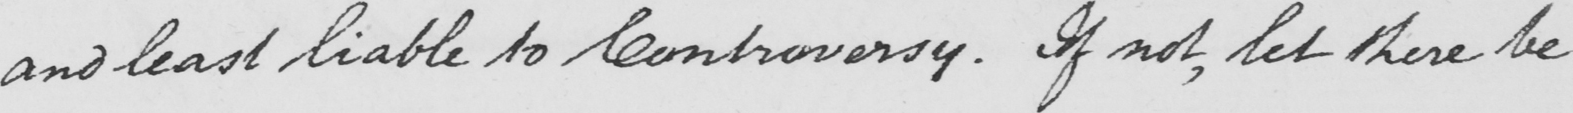Transcribe the text shown in this historical manuscript line. and least liable to Controversy . If not , let there be 